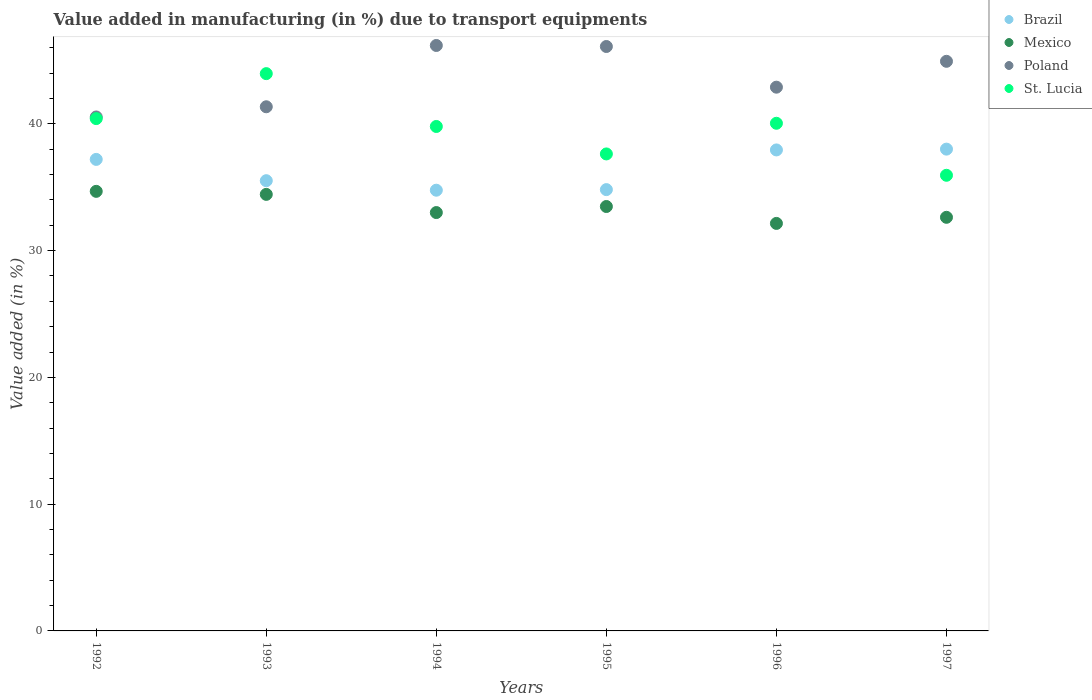How many different coloured dotlines are there?
Make the answer very short. 4. Is the number of dotlines equal to the number of legend labels?
Offer a very short reply. Yes. What is the percentage of value added in manufacturing due to transport equipments in St. Lucia in 1992?
Make the answer very short. 40.41. Across all years, what is the maximum percentage of value added in manufacturing due to transport equipments in Mexico?
Ensure brevity in your answer.  34.68. Across all years, what is the minimum percentage of value added in manufacturing due to transport equipments in St. Lucia?
Give a very brief answer. 35.94. In which year was the percentage of value added in manufacturing due to transport equipments in Mexico maximum?
Provide a succinct answer. 1992. What is the total percentage of value added in manufacturing due to transport equipments in Poland in the graph?
Keep it short and to the point. 262. What is the difference between the percentage of value added in manufacturing due to transport equipments in Brazil in 1992 and that in 1996?
Offer a very short reply. -0.75. What is the difference between the percentage of value added in manufacturing due to transport equipments in Mexico in 1992 and the percentage of value added in manufacturing due to transport equipments in St. Lucia in 1997?
Your response must be concise. -1.27. What is the average percentage of value added in manufacturing due to transport equipments in St. Lucia per year?
Offer a terse response. 39.63. In the year 1997, what is the difference between the percentage of value added in manufacturing due to transport equipments in Mexico and percentage of value added in manufacturing due to transport equipments in Brazil?
Give a very brief answer. -5.38. In how many years, is the percentage of value added in manufacturing due to transport equipments in Mexico greater than 40 %?
Offer a very short reply. 0. What is the ratio of the percentage of value added in manufacturing due to transport equipments in St. Lucia in 1994 to that in 1996?
Make the answer very short. 0.99. Is the difference between the percentage of value added in manufacturing due to transport equipments in Mexico in 1992 and 1994 greater than the difference between the percentage of value added in manufacturing due to transport equipments in Brazil in 1992 and 1994?
Offer a very short reply. No. What is the difference between the highest and the second highest percentage of value added in manufacturing due to transport equipments in St. Lucia?
Give a very brief answer. 3.55. What is the difference between the highest and the lowest percentage of value added in manufacturing due to transport equipments in St. Lucia?
Keep it short and to the point. 8.02. Is it the case that in every year, the sum of the percentage of value added in manufacturing due to transport equipments in Brazil and percentage of value added in manufacturing due to transport equipments in Mexico  is greater than the sum of percentage of value added in manufacturing due to transport equipments in St. Lucia and percentage of value added in manufacturing due to transport equipments in Poland?
Your answer should be very brief. No. Is it the case that in every year, the sum of the percentage of value added in manufacturing due to transport equipments in Mexico and percentage of value added in manufacturing due to transport equipments in Brazil  is greater than the percentage of value added in manufacturing due to transport equipments in Poland?
Offer a very short reply. Yes. Does the percentage of value added in manufacturing due to transport equipments in St. Lucia monotonically increase over the years?
Your answer should be compact. No. Is the percentage of value added in manufacturing due to transport equipments in Brazil strictly greater than the percentage of value added in manufacturing due to transport equipments in Poland over the years?
Keep it short and to the point. No. How many dotlines are there?
Offer a very short reply. 4. Does the graph contain any zero values?
Provide a succinct answer. No. Does the graph contain grids?
Keep it short and to the point. No. How are the legend labels stacked?
Make the answer very short. Vertical. What is the title of the graph?
Ensure brevity in your answer.  Value added in manufacturing (in %) due to transport equipments. What is the label or title of the X-axis?
Provide a succinct answer. Years. What is the label or title of the Y-axis?
Offer a terse response. Value added (in %). What is the Value added (in %) in Brazil in 1992?
Provide a succinct answer. 37.2. What is the Value added (in %) of Mexico in 1992?
Make the answer very short. 34.68. What is the Value added (in %) of Poland in 1992?
Provide a short and direct response. 40.54. What is the Value added (in %) in St. Lucia in 1992?
Keep it short and to the point. 40.41. What is the Value added (in %) in Brazil in 1993?
Offer a terse response. 35.52. What is the Value added (in %) of Mexico in 1993?
Offer a terse response. 34.44. What is the Value added (in %) of Poland in 1993?
Make the answer very short. 41.35. What is the Value added (in %) of St. Lucia in 1993?
Make the answer very short. 43.96. What is the Value added (in %) of Brazil in 1994?
Provide a short and direct response. 34.77. What is the Value added (in %) of Mexico in 1994?
Your response must be concise. 33. What is the Value added (in %) of Poland in 1994?
Make the answer very short. 46.18. What is the Value added (in %) in St. Lucia in 1994?
Offer a very short reply. 39.79. What is the Value added (in %) in Brazil in 1995?
Offer a terse response. 34.81. What is the Value added (in %) in Mexico in 1995?
Provide a short and direct response. 33.48. What is the Value added (in %) of Poland in 1995?
Provide a short and direct response. 46.1. What is the Value added (in %) in St. Lucia in 1995?
Your response must be concise. 37.63. What is the Value added (in %) in Brazil in 1996?
Keep it short and to the point. 37.94. What is the Value added (in %) in Mexico in 1996?
Keep it short and to the point. 32.15. What is the Value added (in %) of Poland in 1996?
Provide a succinct answer. 42.89. What is the Value added (in %) in St. Lucia in 1996?
Your answer should be very brief. 40.05. What is the Value added (in %) in Brazil in 1997?
Provide a short and direct response. 38.01. What is the Value added (in %) in Mexico in 1997?
Offer a terse response. 32.63. What is the Value added (in %) in Poland in 1997?
Make the answer very short. 44.93. What is the Value added (in %) in St. Lucia in 1997?
Provide a short and direct response. 35.94. Across all years, what is the maximum Value added (in %) of Brazil?
Provide a succinct answer. 38.01. Across all years, what is the maximum Value added (in %) of Mexico?
Keep it short and to the point. 34.68. Across all years, what is the maximum Value added (in %) of Poland?
Your response must be concise. 46.18. Across all years, what is the maximum Value added (in %) of St. Lucia?
Provide a succinct answer. 43.96. Across all years, what is the minimum Value added (in %) of Brazil?
Your response must be concise. 34.77. Across all years, what is the minimum Value added (in %) in Mexico?
Offer a terse response. 32.15. Across all years, what is the minimum Value added (in %) of Poland?
Offer a terse response. 40.54. Across all years, what is the minimum Value added (in %) in St. Lucia?
Offer a terse response. 35.94. What is the total Value added (in %) in Brazil in the graph?
Your answer should be compact. 218.24. What is the total Value added (in %) in Mexico in the graph?
Ensure brevity in your answer.  200.37. What is the total Value added (in %) in Poland in the graph?
Your answer should be compact. 262. What is the total Value added (in %) of St. Lucia in the graph?
Offer a very short reply. 237.78. What is the difference between the Value added (in %) of Brazil in 1992 and that in 1993?
Make the answer very short. 1.68. What is the difference between the Value added (in %) in Mexico in 1992 and that in 1993?
Make the answer very short. 0.24. What is the difference between the Value added (in %) in Poland in 1992 and that in 1993?
Provide a succinct answer. -0.8. What is the difference between the Value added (in %) in St. Lucia in 1992 and that in 1993?
Your response must be concise. -3.55. What is the difference between the Value added (in %) of Brazil in 1992 and that in 1994?
Keep it short and to the point. 2.43. What is the difference between the Value added (in %) in Mexico in 1992 and that in 1994?
Provide a succinct answer. 1.67. What is the difference between the Value added (in %) of Poland in 1992 and that in 1994?
Your response must be concise. -5.64. What is the difference between the Value added (in %) of St. Lucia in 1992 and that in 1994?
Provide a succinct answer. 0.62. What is the difference between the Value added (in %) of Brazil in 1992 and that in 1995?
Keep it short and to the point. 2.38. What is the difference between the Value added (in %) in Mexico in 1992 and that in 1995?
Offer a very short reply. 1.2. What is the difference between the Value added (in %) in Poland in 1992 and that in 1995?
Your response must be concise. -5.56. What is the difference between the Value added (in %) in St. Lucia in 1992 and that in 1995?
Ensure brevity in your answer.  2.79. What is the difference between the Value added (in %) of Brazil in 1992 and that in 1996?
Provide a short and direct response. -0.75. What is the difference between the Value added (in %) of Mexico in 1992 and that in 1996?
Ensure brevity in your answer.  2.53. What is the difference between the Value added (in %) in Poland in 1992 and that in 1996?
Your response must be concise. -2.35. What is the difference between the Value added (in %) in St. Lucia in 1992 and that in 1996?
Offer a very short reply. 0.37. What is the difference between the Value added (in %) in Brazil in 1992 and that in 1997?
Offer a terse response. -0.81. What is the difference between the Value added (in %) of Mexico in 1992 and that in 1997?
Offer a terse response. 2.05. What is the difference between the Value added (in %) in Poland in 1992 and that in 1997?
Offer a terse response. -4.39. What is the difference between the Value added (in %) in St. Lucia in 1992 and that in 1997?
Your answer should be compact. 4.47. What is the difference between the Value added (in %) of Brazil in 1993 and that in 1994?
Give a very brief answer. 0.75. What is the difference between the Value added (in %) of Mexico in 1993 and that in 1994?
Offer a terse response. 1.43. What is the difference between the Value added (in %) of Poland in 1993 and that in 1994?
Offer a very short reply. -4.84. What is the difference between the Value added (in %) in St. Lucia in 1993 and that in 1994?
Make the answer very short. 4.17. What is the difference between the Value added (in %) of Brazil in 1993 and that in 1995?
Provide a succinct answer. 0.7. What is the difference between the Value added (in %) of Mexico in 1993 and that in 1995?
Give a very brief answer. 0.96. What is the difference between the Value added (in %) in Poland in 1993 and that in 1995?
Ensure brevity in your answer.  -4.75. What is the difference between the Value added (in %) of St. Lucia in 1993 and that in 1995?
Make the answer very short. 6.33. What is the difference between the Value added (in %) of Brazil in 1993 and that in 1996?
Your answer should be very brief. -2.43. What is the difference between the Value added (in %) in Mexico in 1993 and that in 1996?
Provide a short and direct response. 2.29. What is the difference between the Value added (in %) in Poland in 1993 and that in 1996?
Your answer should be compact. -1.55. What is the difference between the Value added (in %) of St. Lucia in 1993 and that in 1996?
Make the answer very short. 3.92. What is the difference between the Value added (in %) of Brazil in 1993 and that in 1997?
Your answer should be very brief. -2.49. What is the difference between the Value added (in %) of Mexico in 1993 and that in 1997?
Make the answer very short. 1.81. What is the difference between the Value added (in %) in Poland in 1993 and that in 1997?
Offer a very short reply. -3.59. What is the difference between the Value added (in %) in St. Lucia in 1993 and that in 1997?
Keep it short and to the point. 8.02. What is the difference between the Value added (in %) of Brazil in 1994 and that in 1995?
Give a very brief answer. -0.05. What is the difference between the Value added (in %) of Mexico in 1994 and that in 1995?
Offer a terse response. -0.48. What is the difference between the Value added (in %) in Poland in 1994 and that in 1995?
Provide a succinct answer. 0.08. What is the difference between the Value added (in %) of St. Lucia in 1994 and that in 1995?
Keep it short and to the point. 2.17. What is the difference between the Value added (in %) in Brazil in 1994 and that in 1996?
Ensure brevity in your answer.  -3.18. What is the difference between the Value added (in %) of Mexico in 1994 and that in 1996?
Provide a short and direct response. 0.86. What is the difference between the Value added (in %) in Poland in 1994 and that in 1996?
Offer a very short reply. 3.29. What is the difference between the Value added (in %) of St. Lucia in 1994 and that in 1996?
Offer a terse response. -0.25. What is the difference between the Value added (in %) in Brazil in 1994 and that in 1997?
Your answer should be compact. -3.24. What is the difference between the Value added (in %) of Mexico in 1994 and that in 1997?
Offer a very short reply. 0.37. What is the difference between the Value added (in %) in Poland in 1994 and that in 1997?
Give a very brief answer. 1.25. What is the difference between the Value added (in %) in St. Lucia in 1994 and that in 1997?
Offer a terse response. 3.85. What is the difference between the Value added (in %) in Brazil in 1995 and that in 1996?
Give a very brief answer. -3.13. What is the difference between the Value added (in %) of Mexico in 1995 and that in 1996?
Give a very brief answer. 1.33. What is the difference between the Value added (in %) in Poland in 1995 and that in 1996?
Offer a very short reply. 3.21. What is the difference between the Value added (in %) in St. Lucia in 1995 and that in 1996?
Offer a terse response. -2.42. What is the difference between the Value added (in %) in Brazil in 1995 and that in 1997?
Make the answer very short. -3.19. What is the difference between the Value added (in %) in Mexico in 1995 and that in 1997?
Your answer should be very brief. 0.85. What is the difference between the Value added (in %) in Poland in 1995 and that in 1997?
Offer a very short reply. 1.17. What is the difference between the Value added (in %) of St. Lucia in 1995 and that in 1997?
Ensure brevity in your answer.  1.68. What is the difference between the Value added (in %) of Brazil in 1996 and that in 1997?
Provide a short and direct response. -0.06. What is the difference between the Value added (in %) in Mexico in 1996 and that in 1997?
Provide a short and direct response. -0.48. What is the difference between the Value added (in %) in Poland in 1996 and that in 1997?
Offer a terse response. -2.04. What is the difference between the Value added (in %) of St. Lucia in 1996 and that in 1997?
Make the answer very short. 4.1. What is the difference between the Value added (in %) of Brazil in 1992 and the Value added (in %) of Mexico in 1993?
Give a very brief answer. 2.76. What is the difference between the Value added (in %) of Brazil in 1992 and the Value added (in %) of Poland in 1993?
Your response must be concise. -4.15. What is the difference between the Value added (in %) in Brazil in 1992 and the Value added (in %) in St. Lucia in 1993?
Give a very brief answer. -6.77. What is the difference between the Value added (in %) of Mexico in 1992 and the Value added (in %) of Poland in 1993?
Offer a very short reply. -6.67. What is the difference between the Value added (in %) in Mexico in 1992 and the Value added (in %) in St. Lucia in 1993?
Make the answer very short. -9.29. What is the difference between the Value added (in %) of Poland in 1992 and the Value added (in %) of St. Lucia in 1993?
Your answer should be very brief. -3.42. What is the difference between the Value added (in %) of Brazil in 1992 and the Value added (in %) of Mexico in 1994?
Give a very brief answer. 4.19. What is the difference between the Value added (in %) of Brazil in 1992 and the Value added (in %) of Poland in 1994?
Ensure brevity in your answer.  -8.99. What is the difference between the Value added (in %) of Brazil in 1992 and the Value added (in %) of St. Lucia in 1994?
Provide a succinct answer. -2.6. What is the difference between the Value added (in %) of Mexico in 1992 and the Value added (in %) of Poland in 1994?
Provide a short and direct response. -11.51. What is the difference between the Value added (in %) in Mexico in 1992 and the Value added (in %) in St. Lucia in 1994?
Your response must be concise. -5.12. What is the difference between the Value added (in %) of Brazil in 1992 and the Value added (in %) of Mexico in 1995?
Your response must be concise. 3.72. What is the difference between the Value added (in %) of Brazil in 1992 and the Value added (in %) of Poland in 1995?
Give a very brief answer. -8.91. What is the difference between the Value added (in %) of Brazil in 1992 and the Value added (in %) of St. Lucia in 1995?
Your answer should be very brief. -0.43. What is the difference between the Value added (in %) of Mexico in 1992 and the Value added (in %) of Poland in 1995?
Offer a terse response. -11.43. What is the difference between the Value added (in %) in Mexico in 1992 and the Value added (in %) in St. Lucia in 1995?
Provide a short and direct response. -2.95. What is the difference between the Value added (in %) in Poland in 1992 and the Value added (in %) in St. Lucia in 1995?
Offer a very short reply. 2.92. What is the difference between the Value added (in %) in Brazil in 1992 and the Value added (in %) in Mexico in 1996?
Your answer should be compact. 5.05. What is the difference between the Value added (in %) in Brazil in 1992 and the Value added (in %) in Poland in 1996?
Offer a terse response. -5.7. What is the difference between the Value added (in %) of Brazil in 1992 and the Value added (in %) of St. Lucia in 1996?
Your response must be concise. -2.85. What is the difference between the Value added (in %) of Mexico in 1992 and the Value added (in %) of Poland in 1996?
Offer a terse response. -8.22. What is the difference between the Value added (in %) of Mexico in 1992 and the Value added (in %) of St. Lucia in 1996?
Offer a terse response. -5.37. What is the difference between the Value added (in %) of Poland in 1992 and the Value added (in %) of St. Lucia in 1996?
Your response must be concise. 0.5. What is the difference between the Value added (in %) in Brazil in 1992 and the Value added (in %) in Mexico in 1997?
Offer a very short reply. 4.57. What is the difference between the Value added (in %) of Brazil in 1992 and the Value added (in %) of Poland in 1997?
Ensure brevity in your answer.  -7.74. What is the difference between the Value added (in %) in Brazil in 1992 and the Value added (in %) in St. Lucia in 1997?
Give a very brief answer. 1.25. What is the difference between the Value added (in %) of Mexico in 1992 and the Value added (in %) of Poland in 1997?
Give a very brief answer. -10.26. What is the difference between the Value added (in %) in Mexico in 1992 and the Value added (in %) in St. Lucia in 1997?
Make the answer very short. -1.27. What is the difference between the Value added (in %) of Poland in 1992 and the Value added (in %) of St. Lucia in 1997?
Your answer should be compact. 4.6. What is the difference between the Value added (in %) in Brazil in 1993 and the Value added (in %) in Mexico in 1994?
Give a very brief answer. 2.51. What is the difference between the Value added (in %) of Brazil in 1993 and the Value added (in %) of Poland in 1994?
Make the answer very short. -10.67. What is the difference between the Value added (in %) of Brazil in 1993 and the Value added (in %) of St. Lucia in 1994?
Your response must be concise. -4.28. What is the difference between the Value added (in %) in Mexico in 1993 and the Value added (in %) in Poland in 1994?
Make the answer very short. -11.75. What is the difference between the Value added (in %) in Mexico in 1993 and the Value added (in %) in St. Lucia in 1994?
Ensure brevity in your answer.  -5.36. What is the difference between the Value added (in %) in Poland in 1993 and the Value added (in %) in St. Lucia in 1994?
Your answer should be compact. 1.55. What is the difference between the Value added (in %) in Brazil in 1993 and the Value added (in %) in Mexico in 1995?
Provide a short and direct response. 2.04. What is the difference between the Value added (in %) of Brazil in 1993 and the Value added (in %) of Poland in 1995?
Your answer should be compact. -10.59. What is the difference between the Value added (in %) in Brazil in 1993 and the Value added (in %) in St. Lucia in 1995?
Your answer should be compact. -2.11. What is the difference between the Value added (in %) of Mexico in 1993 and the Value added (in %) of Poland in 1995?
Your answer should be very brief. -11.66. What is the difference between the Value added (in %) in Mexico in 1993 and the Value added (in %) in St. Lucia in 1995?
Give a very brief answer. -3.19. What is the difference between the Value added (in %) in Poland in 1993 and the Value added (in %) in St. Lucia in 1995?
Your answer should be compact. 3.72. What is the difference between the Value added (in %) of Brazil in 1993 and the Value added (in %) of Mexico in 1996?
Your response must be concise. 3.37. What is the difference between the Value added (in %) in Brazil in 1993 and the Value added (in %) in Poland in 1996?
Your response must be concise. -7.38. What is the difference between the Value added (in %) in Brazil in 1993 and the Value added (in %) in St. Lucia in 1996?
Keep it short and to the point. -4.53. What is the difference between the Value added (in %) in Mexico in 1993 and the Value added (in %) in Poland in 1996?
Your answer should be compact. -8.46. What is the difference between the Value added (in %) in Mexico in 1993 and the Value added (in %) in St. Lucia in 1996?
Your response must be concise. -5.61. What is the difference between the Value added (in %) in Poland in 1993 and the Value added (in %) in St. Lucia in 1996?
Keep it short and to the point. 1.3. What is the difference between the Value added (in %) of Brazil in 1993 and the Value added (in %) of Mexico in 1997?
Offer a terse response. 2.89. What is the difference between the Value added (in %) in Brazil in 1993 and the Value added (in %) in Poland in 1997?
Ensure brevity in your answer.  -9.42. What is the difference between the Value added (in %) in Brazil in 1993 and the Value added (in %) in St. Lucia in 1997?
Provide a succinct answer. -0.43. What is the difference between the Value added (in %) in Mexico in 1993 and the Value added (in %) in Poland in 1997?
Offer a very short reply. -10.5. What is the difference between the Value added (in %) in Mexico in 1993 and the Value added (in %) in St. Lucia in 1997?
Your answer should be compact. -1.51. What is the difference between the Value added (in %) in Poland in 1993 and the Value added (in %) in St. Lucia in 1997?
Make the answer very short. 5.4. What is the difference between the Value added (in %) of Brazil in 1994 and the Value added (in %) of Mexico in 1995?
Your response must be concise. 1.29. What is the difference between the Value added (in %) of Brazil in 1994 and the Value added (in %) of Poland in 1995?
Your response must be concise. -11.34. What is the difference between the Value added (in %) of Brazil in 1994 and the Value added (in %) of St. Lucia in 1995?
Your answer should be compact. -2.86. What is the difference between the Value added (in %) of Mexico in 1994 and the Value added (in %) of Poland in 1995?
Ensure brevity in your answer.  -13.1. What is the difference between the Value added (in %) of Mexico in 1994 and the Value added (in %) of St. Lucia in 1995?
Give a very brief answer. -4.62. What is the difference between the Value added (in %) in Poland in 1994 and the Value added (in %) in St. Lucia in 1995?
Ensure brevity in your answer.  8.56. What is the difference between the Value added (in %) in Brazil in 1994 and the Value added (in %) in Mexico in 1996?
Provide a succinct answer. 2.62. What is the difference between the Value added (in %) in Brazil in 1994 and the Value added (in %) in Poland in 1996?
Provide a succinct answer. -8.13. What is the difference between the Value added (in %) in Brazil in 1994 and the Value added (in %) in St. Lucia in 1996?
Give a very brief answer. -5.28. What is the difference between the Value added (in %) in Mexico in 1994 and the Value added (in %) in Poland in 1996?
Keep it short and to the point. -9.89. What is the difference between the Value added (in %) of Mexico in 1994 and the Value added (in %) of St. Lucia in 1996?
Offer a terse response. -7.04. What is the difference between the Value added (in %) in Poland in 1994 and the Value added (in %) in St. Lucia in 1996?
Give a very brief answer. 6.14. What is the difference between the Value added (in %) of Brazil in 1994 and the Value added (in %) of Mexico in 1997?
Provide a succinct answer. 2.14. What is the difference between the Value added (in %) of Brazil in 1994 and the Value added (in %) of Poland in 1997?
Your answer should be compact. -10.17. What is the difference between the Value added (in %) of Brazil in 1994 and the Value added (in %) of St. Lucia in 1997?
Your answer should be very brief. -1.18. What is the difference between the Value added (in %) of Mexico in 1994 and the Value added (in %) of Poland in 1997?
Provide a succinct answer. -11.93. What is the difference between the Value added (in %) in Mexico in 1994 and the Value added (in %) in St. Lucia in 1997?
Keep it short and to the point. -2.94. What is the difference between the Value added (in %) in Poland in 1994 and the Value added (in %) in St. Lucia in 1997?
Keep it short and to the point. 10.24. What is the difference between the Value added (in %) in Brazil in 1995 and the Value added (in %) in Mexico in 1996?
Your answer should be compact. 2.67. What is the difference between the Value added (in %) of Brazil in 1995 and the Value added (in %) of Poland in 1996?
Keep it short and to the point. -8.08. What is the difference between the Value added (in %) in Brazil in 1995 and the Value added (in %) in St. Lucia in 1996?
Keep it short and to the point. -5.23. What is the difference between the Value added (in %) of Mexico in 1995 and the Value added (in %) of Poland in 1996?
Keep it short and to the point. -9.41. What is the difference between the Value added (in %) in Mexico in 1995 and the Value added (in %) in St. Lucia in 1996?
Your answer should be very brief. -6.57. What is the difference between the Value added (in %) of Poland in 1995 and the Value added (in %) of St. Lucia in 1996?
Provide a short and direct response. 6.06. What is the difference between the Value added (in %) of Brazil in 1995 and the Value added (in %) of Mexico in 1997?
Offer a very short reply. 2.18. What is the difference between the Value added (in %) in Brazil in 1995 and the Value added (in %) in Poland in 1997?
Your answer should be compact. -10.12. What is the difference between the Value added (in %) in Brazil in 1995 and the Value added (in %) in St. Lucia in 1997?
Ensure brevity in your answer.  -1.13. What is the difference between the Value added (in %) in Mexico in 1995 and the Value added (in %) in Poland in 1997?
Ensure brevity in your answer.  -11.45. What is the difference between the Value added (in %) in Mexico in 1995 and the Value added (in %) in St. Lucia in 1997?
Provide a succinct answer. -2.46. What is the difference between the Value added (in %) in Poland in 1995 and the Value added (in %) in St. Lucia in 1997?
Make the answer very short. 10.16. What is the difference between the Value added (in %) of Brazil in 1996 and the Value added (in %) of Mexico in 1997?
Ensure brevity in your answer.  5.32. What is the difference between the Value added (in %) of Brazil in 1996 and the Value added (in %) of Poland in 1997?
Give a very brief answer. -6.99. What is the difference between the Value added (in %) of Brazil in 1996 and the Value added (in %) of St. Lucia in 1997?
Keep it short and to the point. 2. What is the difference between the Value added (in %) of Mexico in 1996 and the Value added (in %) of Poland in 1997?
Your response must be concise. -12.79. What is the difference between the Value added (in %) in Mexico in 1996 and the Value added (in %) in St. Lucia in 1997?
Give a very brief answer. -3.8. What is the difference between the Value added (in %) of Poland in 1996 and the Value added (in %) of St. Lucia in 1997?
Ensure brevity in your answer.  6.95. What is the average Value added (in %) of Brazil per year?
Keep it short and to the point. 36.37. What is the average Value added (in %) of Mexico per year?
Offer a very short reply. 33.39. What is the average Value added (in %) of Poland per year?
Your answer should be very brief. 43.67. What is the average Value added (in %) of St. Lucia per year?
Your answer should be very brief. 39.63. In the year 1992, what is the difference between the Value added (in %) in Brazil and Value added (in %) in Mexico?
Your response must be concise. 2.52. In the year 1992, what is the difference between the Value added (in %) in Brazil and Value added (in %) in Poland?
Your response must be concise. -3.35. In the year 1992, what is the difference between the Value added (in %) of Brazil and Value added (in %) of St. Lucia?
Offer a very short reply. -3.22. In the year 1992, what is the difference between the Value added (in %) in Mexico and Value added (in %) in Poland?
Provide a succinct answer. -5.87. In the year 1992, what is the difference between the Value added (in %) of Mexico and Value added (in %) of St. Lucia?
Offer a terse response. -5.74. In the year 1992, what is the difference between the Value added (in %) in Poland and Value added (in %) in St. Lucia?
Offer a terse response. 0.13. In the year 1993, what is the difference between the Value added (in %) in Brazil and Value added (in %) in Mexico?
Give a very brief answer. 1.08. In the year 1993, what is the difference between the Value added (in %) in Brazil and Value added (in %) in Poland?
Provide a short and direct response. -5.83. In the year 1993, what is the difference between the Value added (in %) in Brazil and Value added (in %) in St. Lucia?
Ensure brevity in your answer.  -8.44. In the year 1993, what is the difference between the Value added (in %) of Mexico and Value added (in %) of Poland?
Make the answer very short. -6.91. In the year 1993, what is the difference between the Value added (in %) in Mexico and Value added (in %) in St. Lucia?
Make the answer very short. -9.52. In the year 1993, what is the difference between the Value added (in %) in Poland and Value added (in %) in St. Lucia?
Offer a terse response. -2.61. In the year 1994, what is the difference between the Value added (in %) in Brazil and Value added (in %) in Mexico?
Your response must be concise. 1.76. In the year 1994, what is the difference between the Value added (in %) in Brazil and Value added (in %) in Poland?
Provide a short and direct response. -11.42. In the year 1994, what is the difference between the Value added (in %) of Brazil and Value added (in %) of St. Lucia?
Your answer should be compact. -5.03. In the year 1994, what is the difference between the Value added (in %) in Mexico and Value added (in %) in Poland?
Give a very brief answer. -13.18. In the year 1994, what is the difference between the Value added (in %) in Mexico and Value added (in %) in St. Lucia?
Offer a terse response. -6.79. In the year 1994, what is the difference between the Value added (in %) of Poland and Value added (in %) of St. Lucia?
Ensure brevity in your answer.  6.39. In the year 1995, what is the difference between the Value added (in %) in Brazil and Value added (in %) in Mexico?
Your response must be concise. 1.33. In the year 1995, what is the difference between the Value added (in %) in Brazil and Value added (in %) in Poland?
Your response must be concise. -11.29. In the year 1995, what is the difference between the Value added (in %) in Brazil and Value added (in %) in St. Lucia?
Give a very brief answer. -2.81. In the year 1995, what is the difference between the Value added (in %) in Mexico and Value added (in %) in Poland?
Provide a succinct answer. -12.62. In the year 1995, what is the difference between the Value added (in %) in Mexico and Value added (in %) in St. Lucia?
Your response must be concise. -4.15. In the year 1995, what is the difference between the Value added (in %) of Poland and Value added (in %) of St. Lucia?
Your response must be concise. 8.47. In the year 1996, what is the difference between the Value added (in %) of Brazil and Value added (in %) of Mexico?
Your answer should be compact. 5.8. In the year 1996, what is the difference between the Value added (in %) of Brazil and Value added (in %) of Poland?
Your answer should be compact. -4.95. In the year 1996, what is the difference between the Value added (in %) of Brazil and Value added (in %) of St. Lucia?
Your answer should be compact. -2.1. In the year 1996, what is the difference between the Value added (in %) in Mexico and Value added (in %) in Poland?
Offer a terse response. -10.75. In the year 1996, what is the difference between the Value added (in %) in Mexico and Value added (in %) in St. Lucia?
Your answer should be compact. -7.9. In the year 1996, what is the difference between the Value added (in %) of Poland and Value added (in %) of St. Lucia?
Your answer should be compact. 2.85. In the year 1997, what is the difference between the Value added (in %) in Brazil and Value added (in %) in Mexico?
Provide a short and direct response. 5.38. In the year 1997, what is the difference between the Value added (in %) of Brazil and Value added (in %) of Poland?
Offer a very short reply. -6.93. In the year 1997, what is the difference between the Value added (in %) in Brazil and Value added (in %) in St. Lucia?
Provide a short and direct response. 2.06. In the year 1997, what is the difference between the Value added (in %) of Mexico and Value added (in %) of Poland?
Offer a very short reply. -12.31. In the year 1997, what is the difference between the Value added (in %) of Mexico and Value added (in %) of St. Lucia?
Your response must be concise. -3.32. In the year 1997, what is the difference between the Value added (in %) of Poland and Value added (in %) of St. Lucia?
Offer a very short reply. 8.99. What is the ratio of the Value added (in %) in Brazil in 1992 to that in 1993?
Your answer should be very brief. 1.05. What is the ratio of the Value added (in %) of Mexico in 1992 to that in 1993?
Give a very brief answer. 1.01. What is the ratio of the Value added (in %) of Poland in 1992 to that in 1993?
Your answer should be compact. 0.98. What is the ratio of the Value added (in %) in St. Lucia in 1992 to that in 1993?
Your response must be concise. 0.92. What is the ratio of the Value added (in %) of Brazil in 1992 to that in 1994?
Keep it short and to the point. 1.07. What is the ratio of the Value added (in %) of Mexico in 1992 to that in 1994?
Your answer should be very brief. 1.05. What is the ratio of the Value added (in %) in Poland in 1992 to that in 1994?
Offer a terse response. 0.88. What is the ratio of the Value added (in %) of St. Lucia in 1992 to that in 1994?
Offer a terse response. 1.02. What is the ratio of the Value added (in %) of Brazil in 1992 to that in 1995?
Offer a very short reply. 1.07. What is the ratio of the Value added (in %) in Mexico in 1992 to that in 1995?
Provide a short and direct response. 1.04. What is the ratio of the Value added (in %) in Poland in 1992 to that in 1995?
Ensure brevity in your answer.  0.88. What is the ratio of the Value added (in %) in St. Lucia in 1992 to that in 1995?
Keep it short and to the point. 1.07. What is the ratio of the Value added (in %) of Brazil in 1992 to that in 1996?
Keep it short and to the point. 0.98. What is the ratio of the Value added (in %) of Mexico in 1992 to that in 1996?
Your answer should be very brief. 1.08. What is the ratio of the Value added (in %) in Poland in 1992 to that in 1996?
Give a very brief answer. 0.95. What is the ratio of the Value added (in %) of St. Lucia in 1992 to that in 1996?
Offer a terse response. 1.01. What is the ratio of the Value added (in %) in Brazil in 1992 to that in 1997?
Ensure brevity in your answer.  0.98. What is the ratio of the Value added (in %) in Mexico in 1992 to that in 1997?
Your answer should be compact. 1.06. What is the ratio of the Value added (in %) in Poland in 1992 to that in 1997?
Make the answer very short. 0.9. What is the ratio of the Value added (in %) in St. Lucia in 1992 to that in 1997?
Give a very brief answer. 1.12. What is the ratio of the Value added (in %) in Brazil in 1993 to that in 1994?
Keep it short and to the point. 1.02. What is the ratio of the Value added (in %) in Mexico in 1993 to that in 1994?
Give a very brief answer. 1.04. What is the ratio of the Value added (in %) in Poland in 1993 to that in 1994?
Your response must be concise. 0.9. What is the ratio of the Value added (in %) in St. Lucia in 1993 to that in 1994?
Provide a short and direct response. 1.1. What is the ratio of the Value added (in %) of Brazil in 1993 to that in 1995?
Your answer should be compact. 1.02. What is the ratio of the Value added (in %) of Mexico in 1993 to that in 1995?
Ensure brevity in your answer.  1.03. What is the ratio of the Value added (in %) of Poland in 1993 to that in 1995?
Give a very brief answer. 0.9. What is the ratio of the Value added (in %) of St. Lucia in 1993 to that in 1995?
Ensure brevity in your answer.  1.17. What is the ratio of the Value added (in %) in Brazil in 1993 to that in 1996?
Your answer should be compact. 0.94. What is the ratio of the Value added (in %) of Mexico in 1993 to that in 1996?
Keep it short and to the point. 1.07. What is the ratio of the Value added (in %) in Poland in 1993 to that in 1996?
Make the answer very short. 0.96. What is the ratio of the Value added (in %) of St. Lucia in 1993 to that in 1996?
Your response must be concise. 1.1. What is the ratio of the Value added (in %) of Brazil in 1993 to that in 1997?
Your answer should be very brief. 0.93. What is the ratio of the Value added (in %) in Mexico in 1993 to that in 1997?
Provide a short and direct response. 1.06. What is the ratio of the Value added (in %) of Poland in 1993 to that in 1997?
Keep it short and to the point. 0.92. What is the ratio of the Value added (in %) in St. Lucia in 1993 to that in 1997?
Offer a very short reply. 1.22. What is the ratio of the Value added (in %) in Mexico in 1994 to that in 1995?
Make the answer very short. 0.99. What is the ratio of the Value added (in %) in St. Lucia in 1994 to that in 1995?
Offer a very short reply. 1.06. What is the ratio of the Value added (in %) of Brazil in 1994 to that in 1996?
Provide a succinct answer. 0.92. What is the ratio of the Value added (in %) of Mexico in 1994 to that in 1996?
Offer a very short reply. 1.03. What is the ratio of the Value added (in %) of Poland in 1994 to that in 1996?
Offer a very short reply. 1.08. What is the ratio of the Value added (in %) in Brazil in 1994 to that in 1997?
Give a very brief answer. 0.91. What is the ratio of the Value added (in %) in Mexico in 1994 to that in 1997?
Your response must be concise. 1.01. What is the ratio of the Value added (in %) in Poland in 1994 to that in 1997?
Offer a very short reply. 1.03. What is the ratio of the Value added (in %) in St. Lucia in 1994 to that in 1997?
Give a very brief answer. 1.11. What is the ratio of the Value added (in %) of Brazil in 1995 to that in 1996?
Provide a short and direct response. 0.92. What is the ratio of the Value added (in %) in Mexico in 1995 to that in 1996?
Ensure brevity in your answer.  1.04. What is the ratio of the Value added (in %) in Poland in 1995 to that in 1996?
Keep it short and to the point. 1.07. What is the ratio of the Value added (in %) of St. Lucia in 1995 to that in 1996?
Provide a short and direct response. 0.94. What is the ratio of the Value added (in %) in Brazil in 1995 to that in 1997?
Provide a short and direct response. 0.92. What is the ratio of the Value added (in %) of Mexico in 1995 to that in 1997?
Offer a terse response. 1.03. What is the ratio of the Value added (in %) of Poland in 1995 to that in 1997?
Ensure brevity in your answer.  1.03. What is the ratio of the Value added (in %) of St. Lucia in 1995 to that in 1997?
Your answer should be compact. 1.05. What is the ratio of the Value added (in %) of Mexico in 1996 to that in 1997?
Provide a short and direct response. 0.99. What is the ratio of the Value added (in %) of Poland in 1996 to that in 1997?
Offer a terse response. 0.95. What is the ratio of the Value added (in %) in St. Lucia in 1996 to that in 1997?
Keep it short and to the point. 1.11. What is the difference between the highest and the second highest Value added (in %) in Brazil?
Make the answer very short. 0.06. What is the difference between the highest and the second highest Value added (in %) in Mexico?
Provide a short and direct response. 0.24. What is the difference between the highest and the second highest Value added (in %) in Poland?
Offer a very short reply. 0.08. What is the difference between the highest and the second highest Value added (in %) in St. Lucia?
Offer a terse response. 3.55. What is the difference between the highest and the lowest Value added (in %) of Brazil?
Provide a short and direct response. 3.24. What is the difference between the highest and the lowest Value added (in %) of Mexico?
Keep it short and to the point. 2.53. What is the difference between the highest and the lowest Value added (in %) of Poland?
Provide a succinct answer. 5.64. What is the difference between the highest and the lowest Value added (in %) in St. Lucia?
Your response must be concise. 8.02. 